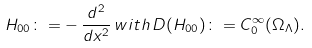<formula> <loc_0><loc_0><loc_500><loc_500>H _ { 0 0 } \colon = - \, \frac { d ^ { 2 } } { d x ^ { 2 } } \, w i t h \, D ( H _ { 0 0 } ) \colon = C _ { 0 } ^ { \infty } ( \Omega _ { \Lambda } ) .</formula> 